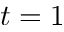<formula> <loc_0><loc_0><loc_500><loc_500>t = 1</formula> 